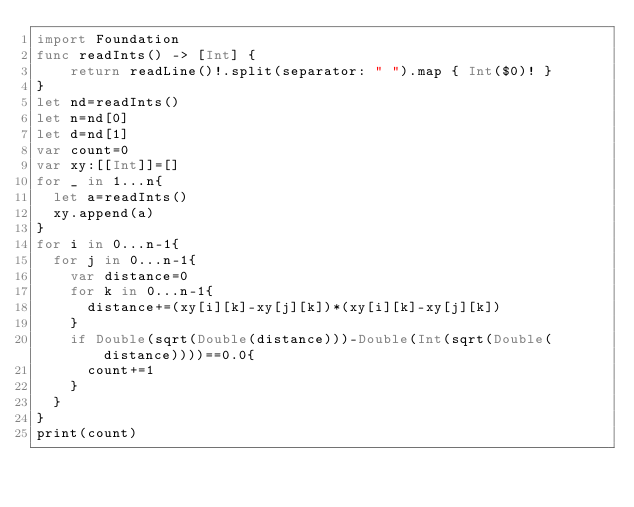<code> <loc_0><loc_0><loc_500><loc_500><_Swift_>import Foundation
func readInts() -> [Int] {
    return readLine()!.split(separator: " ").map { Int($0)! }
}
let nd=readInts()
let n=nd[0]
let d=nd[1]
var count=0
var xy:[[Int]]=[]
for _ in 1...n{
  let a=readInts()
  xy.append(a)
}
for i in 0...n-1{
  for j in 0...n-1{
    var distance=0
    for k in 0...n-1{
      distance+=(xy[i][k]-xy[j][k])*(xy[i][k]-xy[j][k])
    }
    if Double(sqrt(Double(distance)))-Double(Int(sqrt(Double(distance))))==0.0{
      count+=1
    }
  }
}
print(count)

</code> 